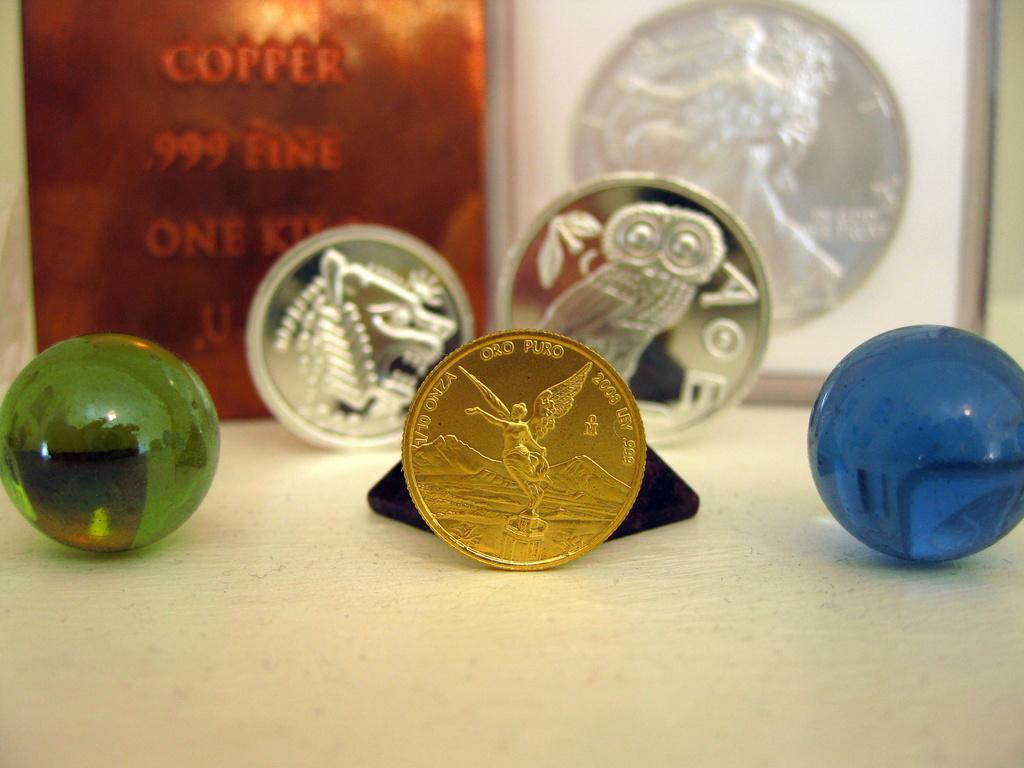What objects can be seen in the image? There are coins and marbles in the image. Are there any other items visible on the table? Yes, there are frames on the back of the table in the image. What texture can be felt on the marbles in the image? The texture of the marbles cannot be determined from the image alone, as it only provides visual information. 